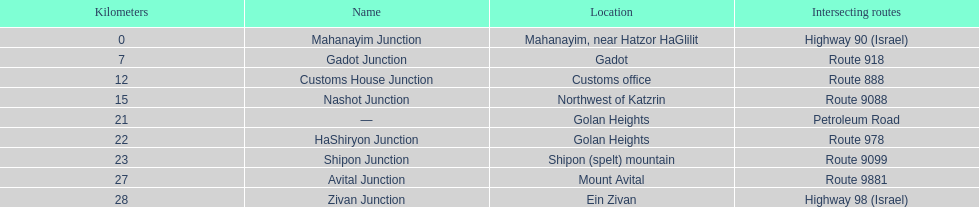What is the total distance in kilometers between mahanayim junction and shipon junction? 23. 